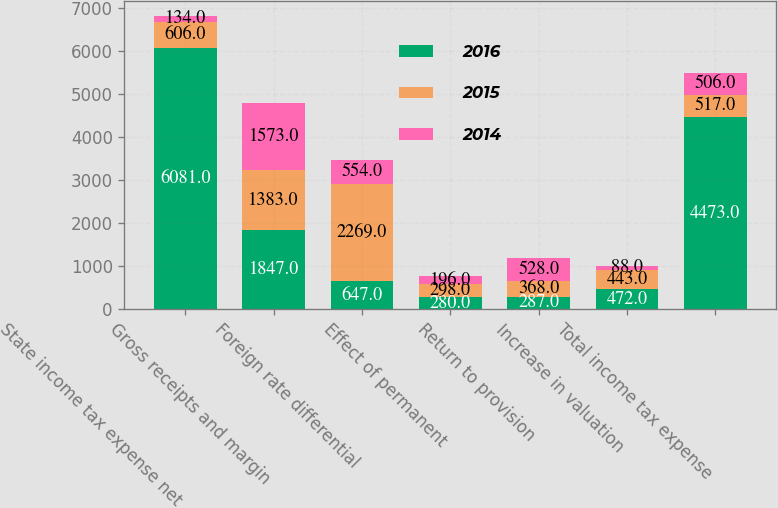<chart> <loc_0><loc_0><loc_500><loc_500><stacked_bar_chart><ecel><fcel>State income tax expense net<fcel>Gross receipts and margin<fcel>Foreign rate differential<fcel>Effect of permanent<fcel>Return to provision<fcel>Increase in valuation<fcel>Total income tax expense<nl><fcel>2016<fcel>6081<fcel>1847<fcel>647<fcel>280<fcel>287<fcel>472<fcel>4473<nl><fcel>2015<fcel>606<fcel>1383<fcel>2269<fcel>298<fcel>368<fcel>443<fcel>517<nl><fcel>2014<fcel>134<fcel>1573<fcel>554<fcel>196<fcel>528<fcel>88<fcel>506<nl></chart> 